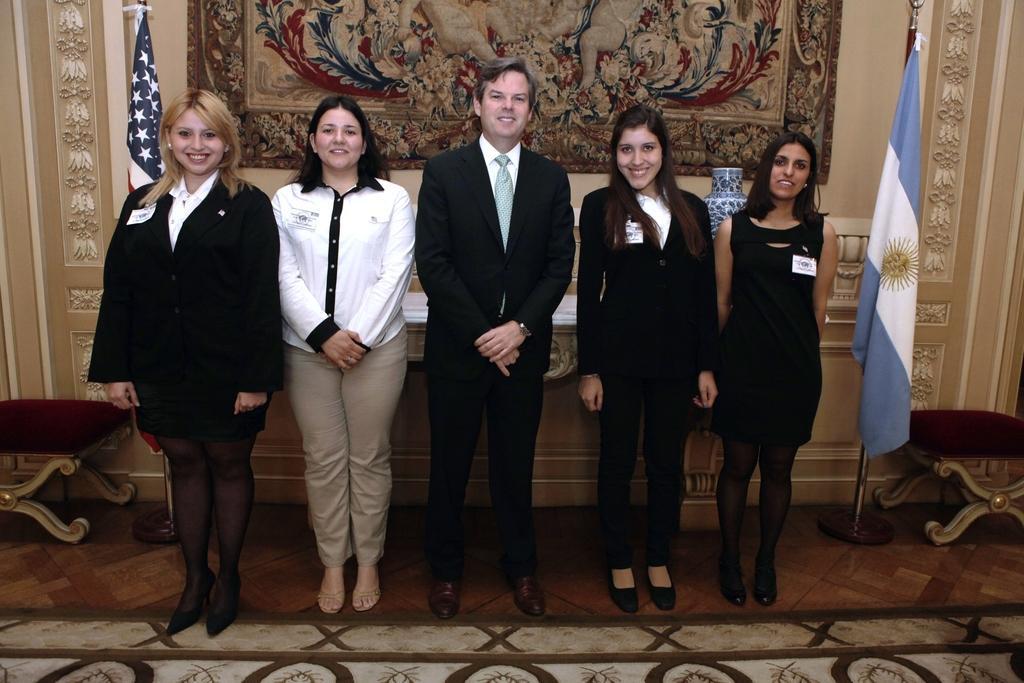Please provide a concise description of this image. In this image we can see a few people, behind them there is a vase on the table, there are chairs, also we can see the flags, and the designed wall. 